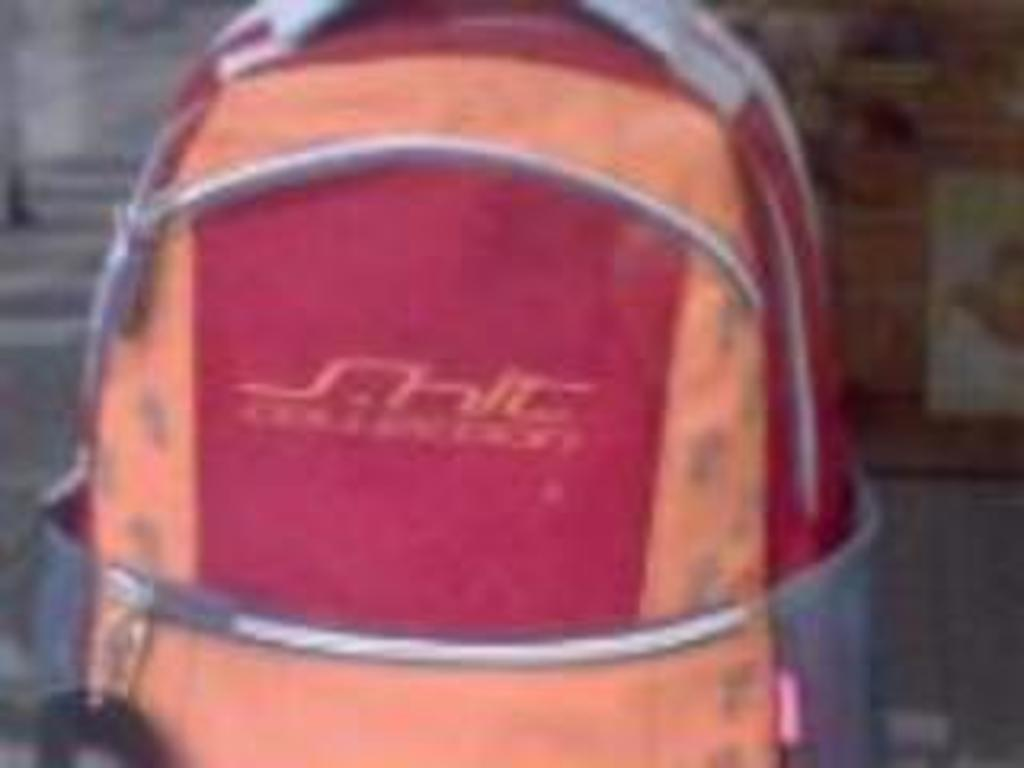What object can be seen in the image? There is a bag in the image. What colors are present on the bag? The bag has orange and red colors. Where is the bag located in the image? The bag is placed on the floor. What is the color of the floor in the image? The floor has a somewhat blue color. Can you see any sheets being used in the image? There is no mention of sheets in the provided facts, so we cannot determine if any are present in the image. 